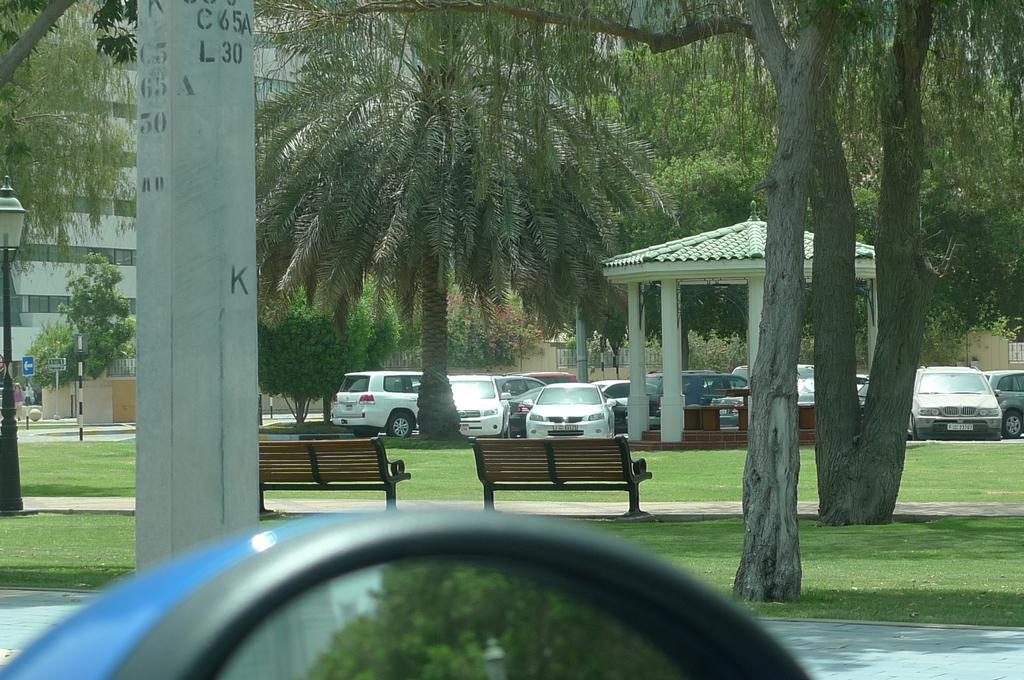Could you give a brief overview of what you see in this image? In this image I can see a mirror like thing in the front. In the background I can see a road, an open grass ground, a pole and on it again see something is written. I can also see number of trees, two benches, a shed, number of vehicles and few buildings. On the left side of the image I can see few poles, few people and a sign board. 